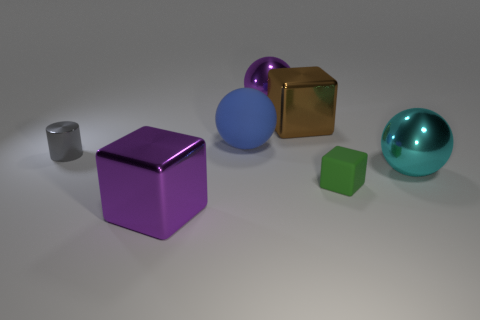How big is the matte thing that is in front of the small thing on the left side of the block that is behind the blue sphere?
Your response must be concise. Small. There is a large purple shiny thing that is behind the purple metal cube; what number of metallic objects are right of it?
Your response must be concise. 2. There is a metal object that is both left of the rubber ball and behind the tiny green matte thing; what size is it?
Your response must be concise. Small. What number of metallic objects are either tiny gray cylinders or cubes?
Give a very brief answer. 3. What is the material of the cylinder?
Give a very brief answer. Metal. There is a purple object behind the metal ball that is right of the big metal sphere to the left of the green thing; what is it made of?
Ensure brevity in your answer.  Metal. The cyan object that is the same size as the matte ball is what shape?
Offer a terse response. Sphere. What number of things are tiny red metal things or things in front of the small shiny object?
Keep it short and to the point. 3. Do the large ball that is right of the purple metallic ball and the small object that is in front of the tiny metal cylinder have the same material?
Offer a very short reply. No. What number of cyan objects are either big cubes or balls?
Give a very brief answer. 1. 